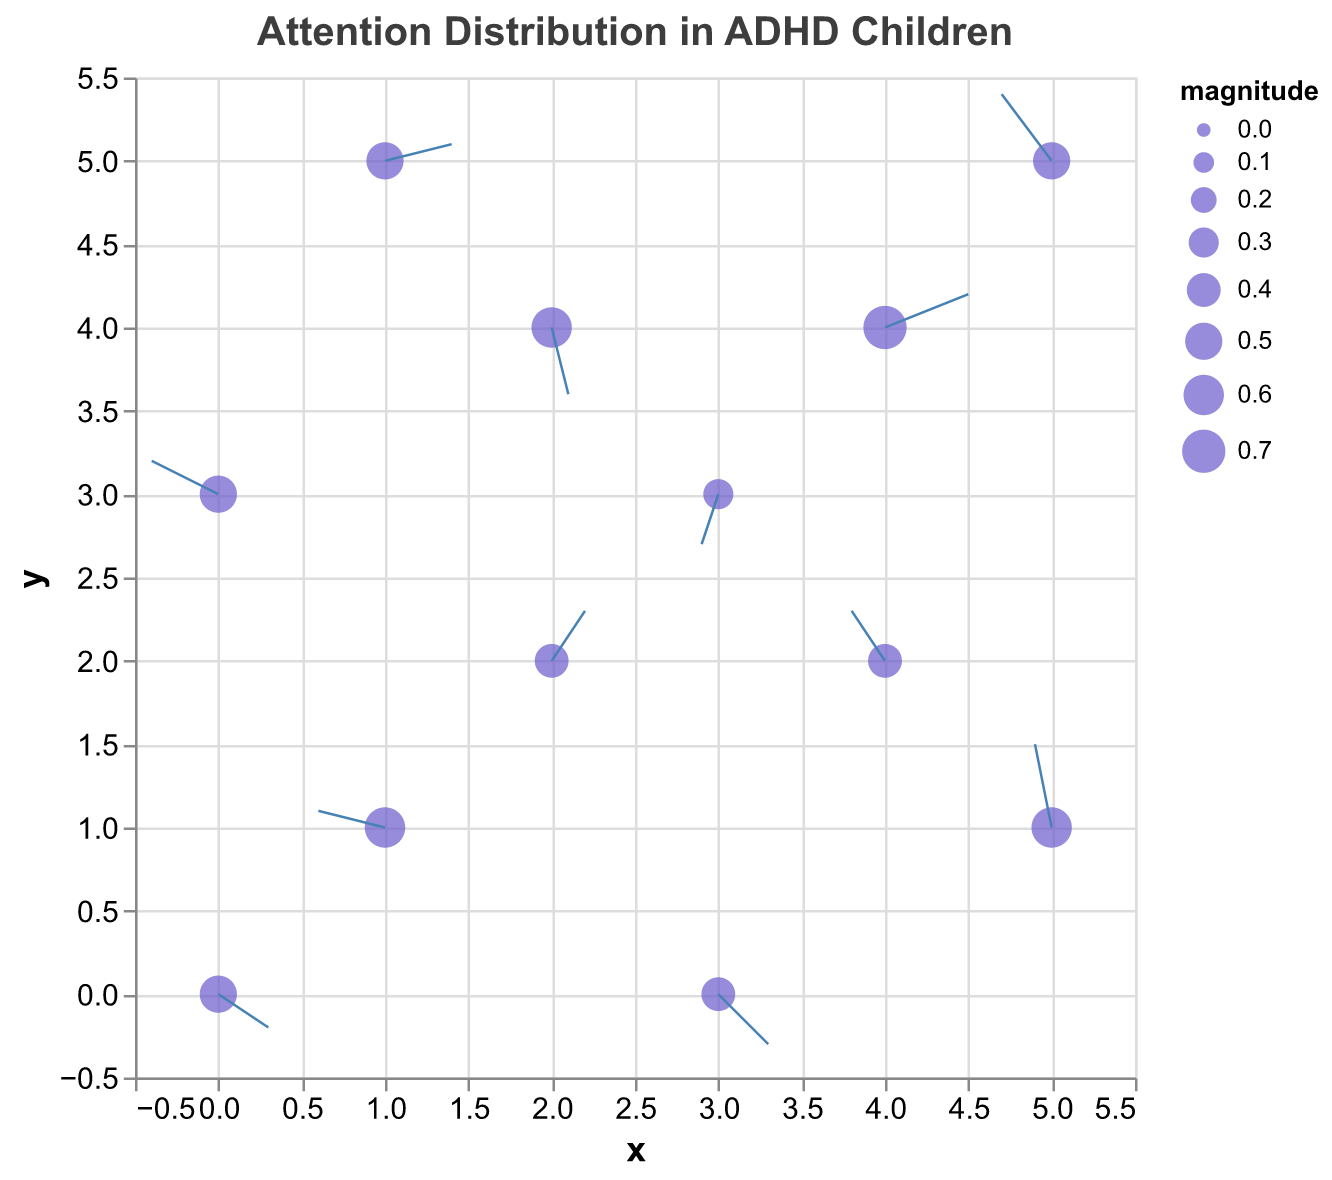What's the title of the figure? The title of the figure is displayed at the top and provides an overview of the data being presented.
Answer: Attention Distribution in ADHD Children What are the ranges of the x and y axes? The x and y axes both range from -0.5 to 5.5, as can be seen from the axis ticks.
Answer: [-0.5, 5.5] Which data point has the highest magnitude? The data point with coordinates (4,4) has the highest magnitude of 0.7, as indicated by the largest point size.
Answer: (4, 4) How many quiver arrows point downward? To count the arrows pointing downward, observe the vertical components (v) of each arrow: those with negative values point downward. The arrows at (0,0), (3,3), (2,4), (3,0) fulfill this condition. Therefore, there are four arrows pointing downward.
Answer: 4 Which direction does the arrow at point (5,1) point? The arrow at (5,1) has u = -0.1 and v = 0.5, indicating it points slightly left and sharply upwards.
Answer: Up-left What is the average magnitude of all quiver arrows? To find the average magnitude, sum all magnitudes and divide by the number of points: (0.5 + 0.6 + 0.4 + 0.3 + 0.7 + 0.5 + 0.6 + 0.4 + 0.5 + 0.6 + 0.4 + 0.5) = 6.0. There are 12 data points, so the average is 6.0 / 12 = 0.50.
Answer: 0.50 Which data point has the largest horizontal component (u)? The data point with the largest horizontal component u is (4, 4) with u = 0.5, indicating the longest arrow in the horizontal direction.
Answer: (4, 4) Which arrows point roughly in the same direction? Arrows pointing in the same direction will have similar u and v values. The arrows at (2,2) and (4,2) both point generally upward-right with u = 0.2, v = 0.3 and u = -0.2, v = 0.3 respectively.
Answer: (2, 2) and (4, 2) How many data points have a horizontal component to the left (negative u value)? Check for points with a negative u value: (1,1), (3,3), (5, 5), (4, 2), (5, 1), and (0, 3). There are 6 such points.
Answer: 6 